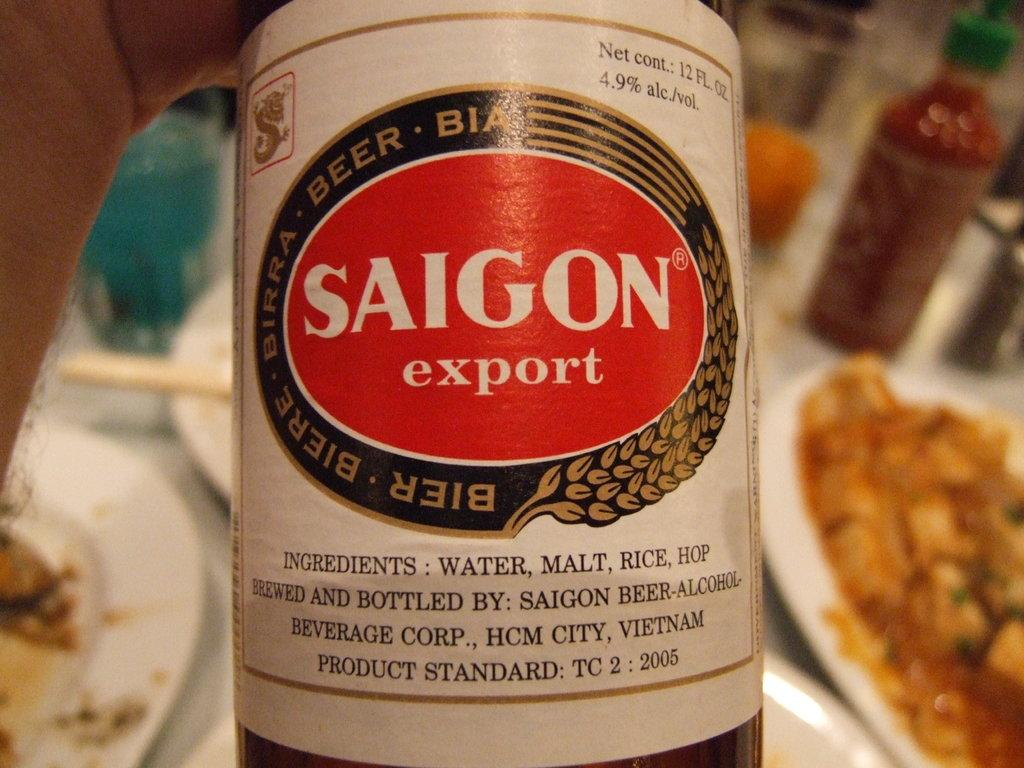<image>
Create a compact narrative representing the image presented. The label of Saigon export beer is white with a red oval. 